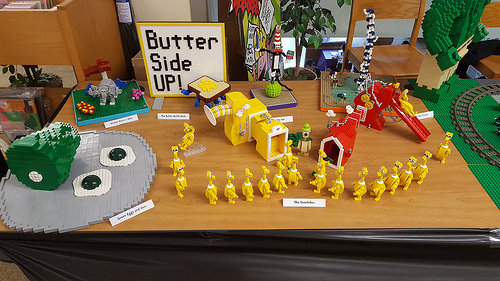<image>
Can you confirm if the lego ham is to the left of the lego egg? Yes. From this viewpoint, the lego ham is positioned to the left side relative to the lego egg. 